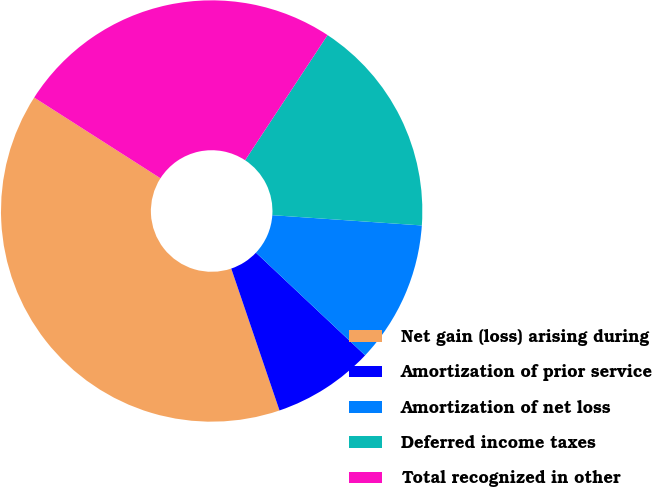Convert chart to OTSL. <chart><loc_0><loc_0><loc_500><loc_500><pie_chart><fcel>Net gain (loss) arising during<fcel>Amortization of prior service<fcel>Amortization of net loss<fcel>Deferred income taxes<fcel>Total recognized in other<nl><fcel>39.27%<fcel>7.77%<fcel>10.92%<fcel>16.82%<fcel>25.22%<nl></chart> 